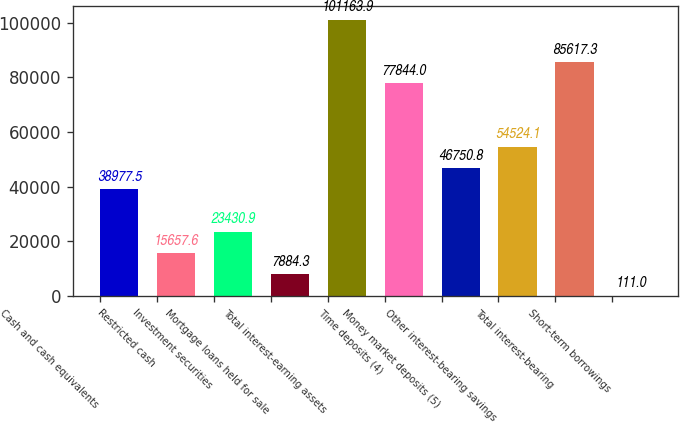<chart> <loc_0><loc_0><loc_500><loc_500><bar_chart><fcel>Cash and cash equivalents<fcel>Restricted cash<fcel>Investment securities<fcel>Mortgage loans held for sale<fcel>Total interest-earning assets<fcel>Time deposits (4)<fcel>Money market deposits (5)<fcel>Other interest-bearing savings<fcel>Total interest-bearing<fcel>Short-term borrowings<nl><fcel>38977.5<fcel>15657.6<fcel>23430.9<fcel>7884.3<fcel>101164<fcel>77844<fcel>46750.8<fcel>54524.1<fcel>85617.3<fcel>111<nl></chart> 